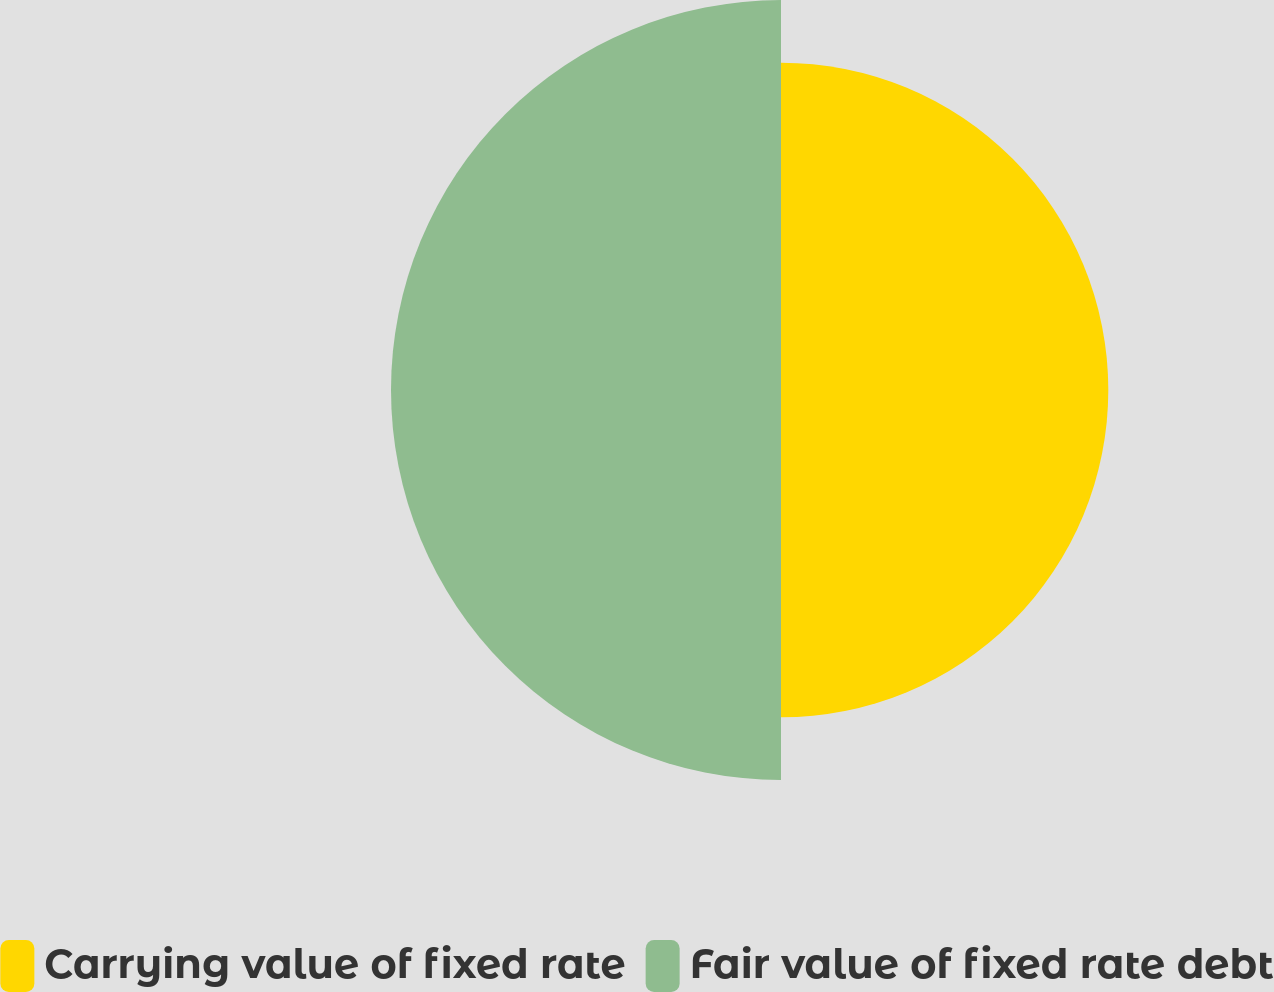Convert chart. <chart><loc_0><loc_0><loc_500><loc_500><pie_chart><fcel>Carrying value of fixed rate<fcel>Fair value of fixed rate debt<nl><fcel>45.63%<fcel>54.37%<nl></chart> 